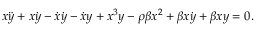<formula> <loc_0><loc_0><loc_500><loc_500>x \ddot { y } + x \dot { y } - \dot { x } \dot { y } - \dot { x } y + x ^ { 3 } y - \rho \beta x ^ { 2 } + \beta x \dot { y } + \beta x y = 0 .</formula> 